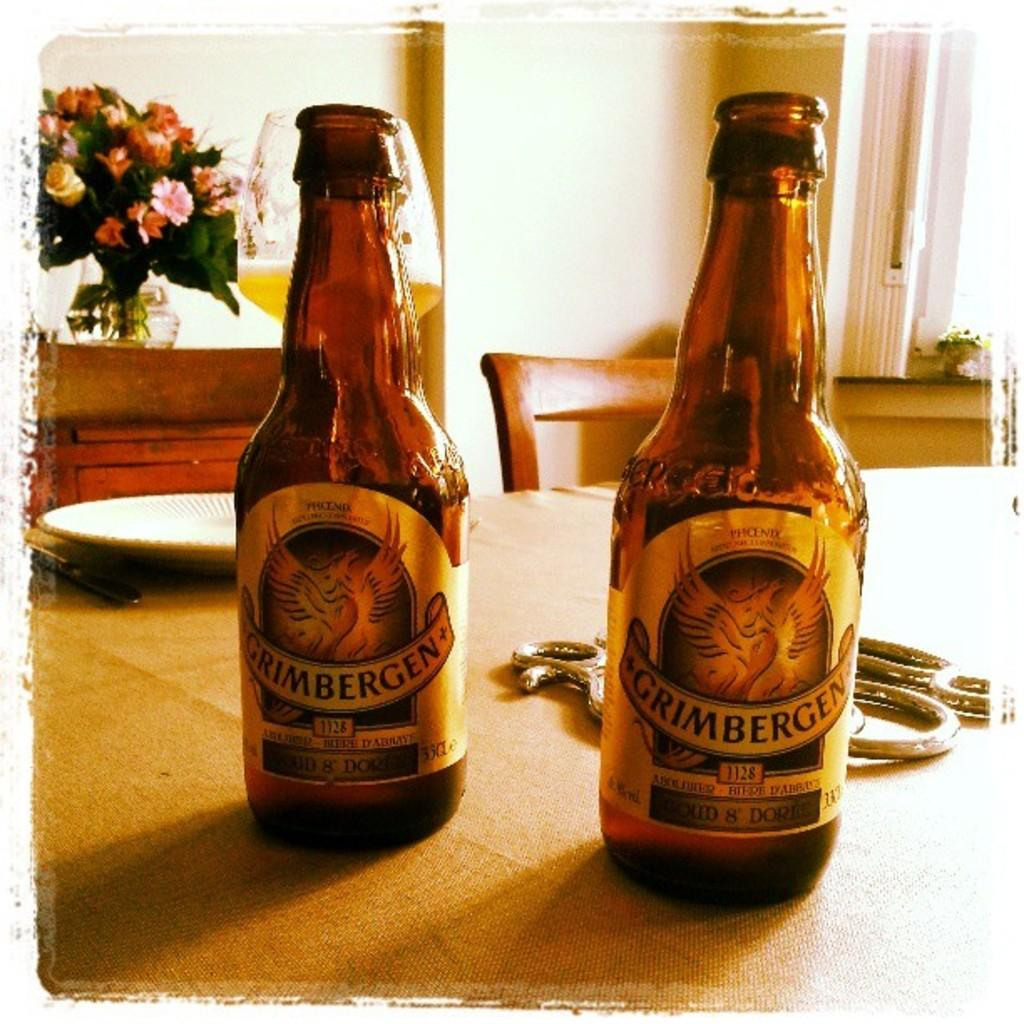<image>
Present a compact description of the photo's key features. Two bottles of Grimbergen beer sit at the kitchen table. 